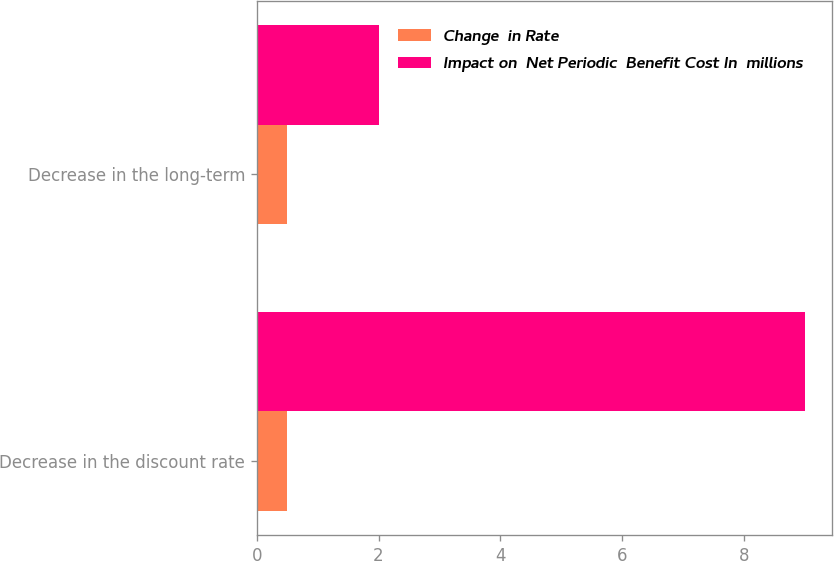Convert chart. <chart><loc_0><loc_0><loc_500><loc_500><stacked_bar_chart><ecel><fcel>Decrease in the discount rate<fcel>Decrease in the long-term<nl><fcel>Change  in Rate<fcel>0.5<fcel>0.5<nl><fcel>Impact on  Net Periodic  Benefit Cost In  millions<fcel>9<fcel>2<nl></chart> 